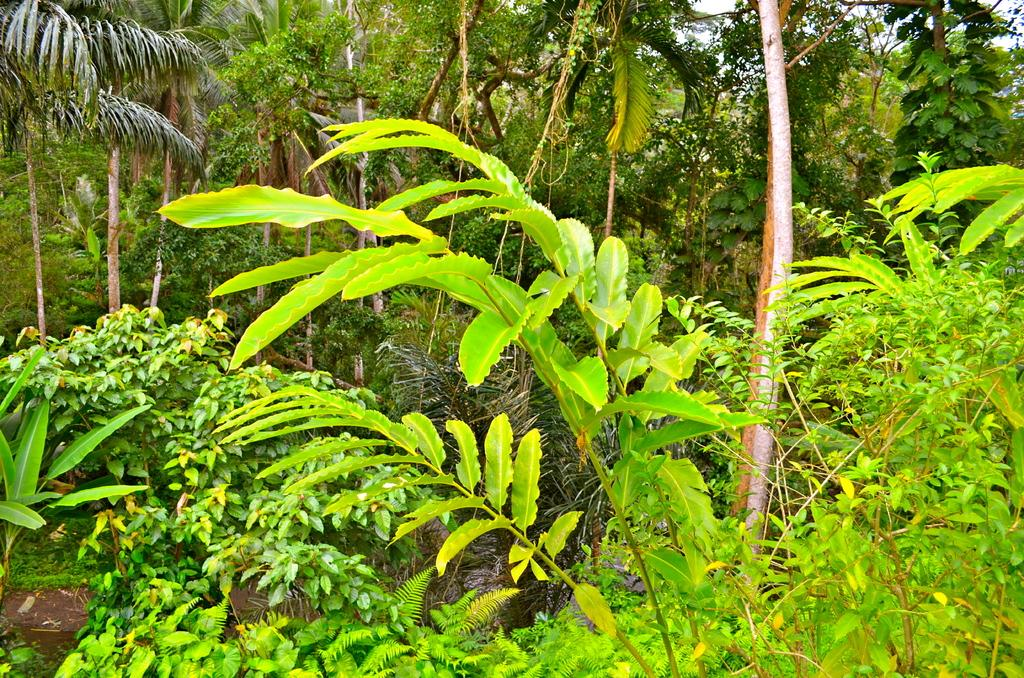What is the primary feature visible in the image? There are many trees in the image. Can you describe the landscape in the image? The landscape in the image is dominated by trees. What type of environment might this image depict? The image might depict a forest or wooded area, given the presence of many trees. What type of marble is visible in the image? There is no marble present in the image; it features many trees. What flavor of light can be seen in the image? The image does not depict any type of light or flavor; it features many trees. 